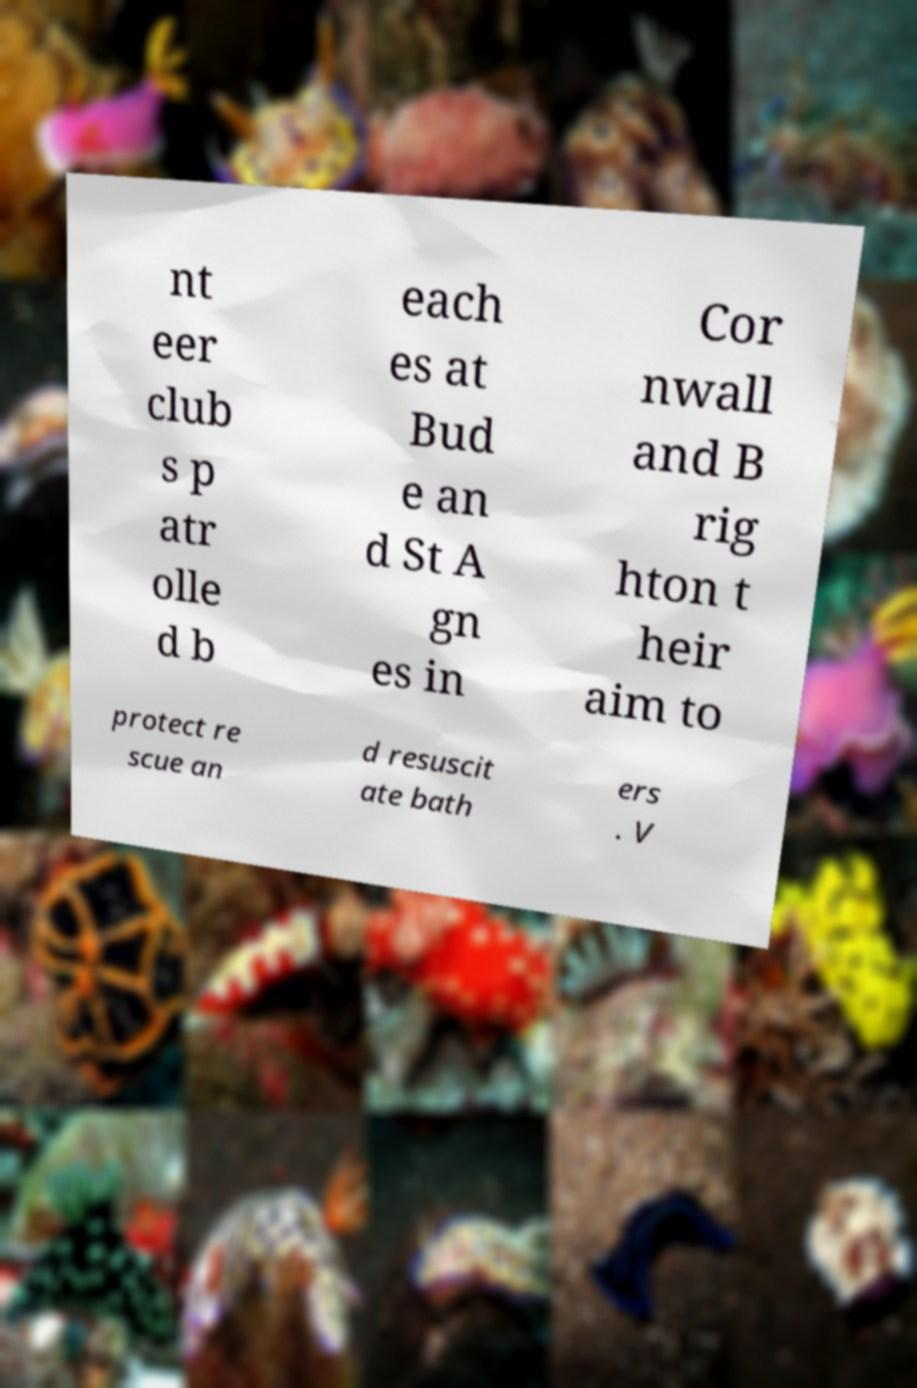I need the written content from this picture converted into text. Can you do that? nt eer club s p atr olle d b each es at Bud e an d St A gn es in Cor nwall and B rig hton t heir aim to protect re scue an d resuscit ate bath ers . V 